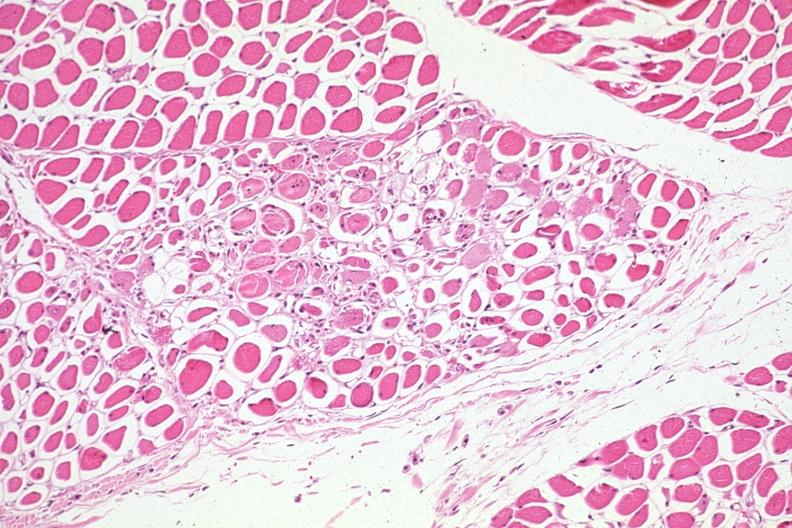s pituitary present?
Answer the question using a single word or phrase. No 